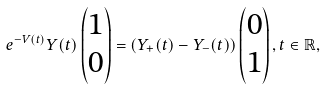<formula> <loc_0><loc_0><loc_500><loc_500>e ^ { - V ( t ) } Y ( t ) \begin{pmatrix} 1 \\ 0 \end{pmatrix} = \left ( Y _ { + } ( t ) - Y _ { - } ( t ) \right ) \begin{pmatrix} 0 \\ 1 \end{pmatrix} , t \in \mathbb { R } ,</formula> 